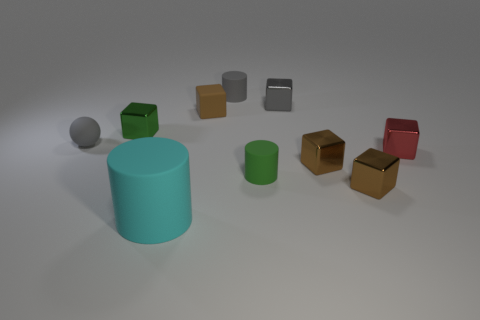There is a cylinder that is the same color as the sphere; what material is it?
Offer a very short reply. Rubber. How many small matte spheres are there?
Make the answer very short. 1. There is a rubber cylinder that is behind the small red cube; what color is it?
Offer a very short reply. Gray. What is the size of the matte sphere?
Ensure brevity in your answer.  Small. There is a big matte cylinder; is its color the same as the tiny matte cylinder in front of the brown matte thing?
Your answer should be compact. No. What is the color of the tiny cylinder on the left side of the tiny matte object that is in front of the tiny red shiny thing?
Your response must be concise. Gray. Is there any other thing that has the same size as the red shiny block?
Your answer should be very brief. Yes. There is a small object in front of the green matte object; is it the same shape as the tiny gray metal object?
Your answer should be compact. Yes. How many small objects are left of the gray matte cylinder and behind the rubber sphere?
Your response must be concise. 2. The metal object left of the rubber cylinder that is on the left side of the tiny matte thing behind the tiny gray block is what color?
Provide a short and direct response. Green. 